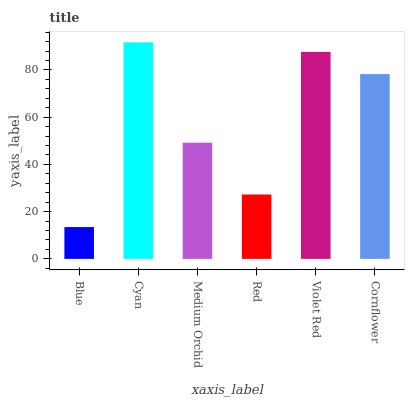Is Blue the minimum?
Answer yes or no. Yes. Is Cyan the maximum?
Answer yes or no. Yes. Is Medium Orchid the minimum?
Answer yes or no. No. Is Medium Orchid the maximum?
Answer yes or no. No. Is Cyan greater than Medium Orchid?
Answer yes or no. Yes. Is Medium Orchid less than Cyan?
Answer yes or no. Yes. Is Medium Orchid greater than Cyan?
Answer yes or no. No. Is Cyan less than Medium Orchid?
Answer yes or no. No. Is Cornflower the high median?
Answer yes or no. Yes. Is Medium Orchid the low median?
Answer yes or no. Yes. Is Blue the high median?
Answer yes or no. No. Is Cornflower the low median?
Answer yes or no. No. 